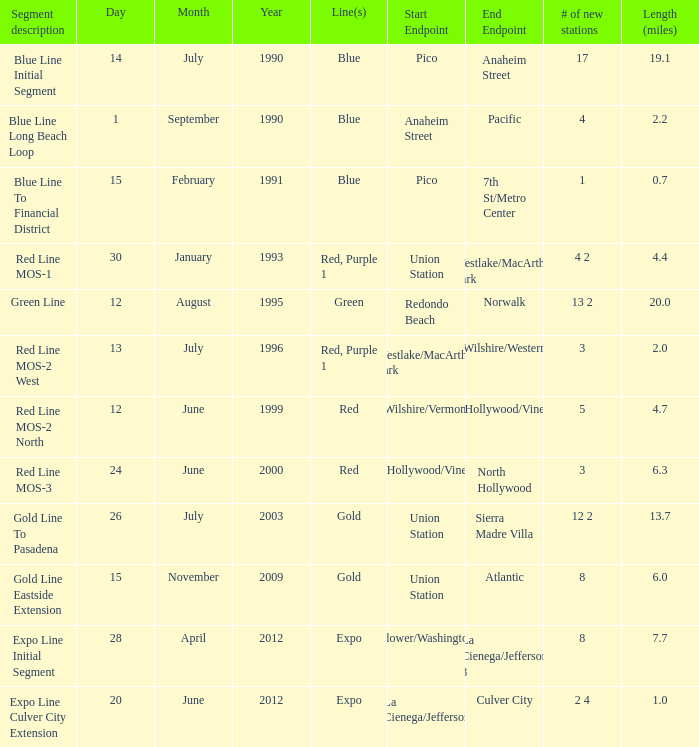How many new stations have a lenght (miles) of 6.0? 1.0. Could you help me parse every detail presented in this table? {'header': ['Segment description', 'Day', 'Month', 'Year', 'Line(s)', 'Start Endpoint', 'End Endpoint', '# of new stations', 'Length (miles)'], 'rows': [['Blue Line Initial Segment', '14', 'July', '1990', 'Blue', 'Pico', 'Anaheim Street', '17', '19.1'], ['Blue Line Long Beach Loop', '1', 'September', '1990', 'Blue', 'Anaheim Street', 'Pacific', '4', '2.2'], ['Blue Line To Financial District', '15', 'February', '1991', 'Blue', 'Pico', '7th St/Metro Center', '1', '0.7'], ['Red Line MOS-1', '30', 'January', '1993', 'Red, Purple 1', 'Union Station', 'Westlake/MacArthur Park', '4 2', '4.4'], ['Green Line', '12', 'August', '1995', 'Green', 'Redondo Beach', 'Norwalk', '13 2', '20.0'], ['Red Line MOS-2 West', '13', 'July', '1996', 'Red, Purple 1', 'Westlake/MacArthur Park', 'Wilshire/Western', '3', '2.0'], ['Red Line MOS-2 North', '12', 'June', '1999', 'Red', 'Wilshire/Vermont', 'Hollywood/Vine', '5', '4.7'], ['Red Line MOS-3', '24', 'June', '2000', 'Red', 'Hollywood/Vine', 'North Hollywood', '3', '6.3'], ['Gold Line To Pasadena', '26', 'July', '2003', 'Gold', 'Union Station', 'Sierra Madre Villa', '12 2', '13.7'], ['Gold Line Eastside Extension', '15', 'November', '2009', 'Gold', 'Union Station', 'Atlantic', '8', '6.0'], ['Expo Line Initial Segment', '28', 'April', '2012', 'Expo', 'Flower/Washington', 'La Cienega/Jefferson 3', '8', '7.7'], ['Expo Line Culver City Extension', '20', 'June', '2012', 'Expo', 'La Cienega/Jefferson', 'Culver City', '2 4', '1.0']]} 